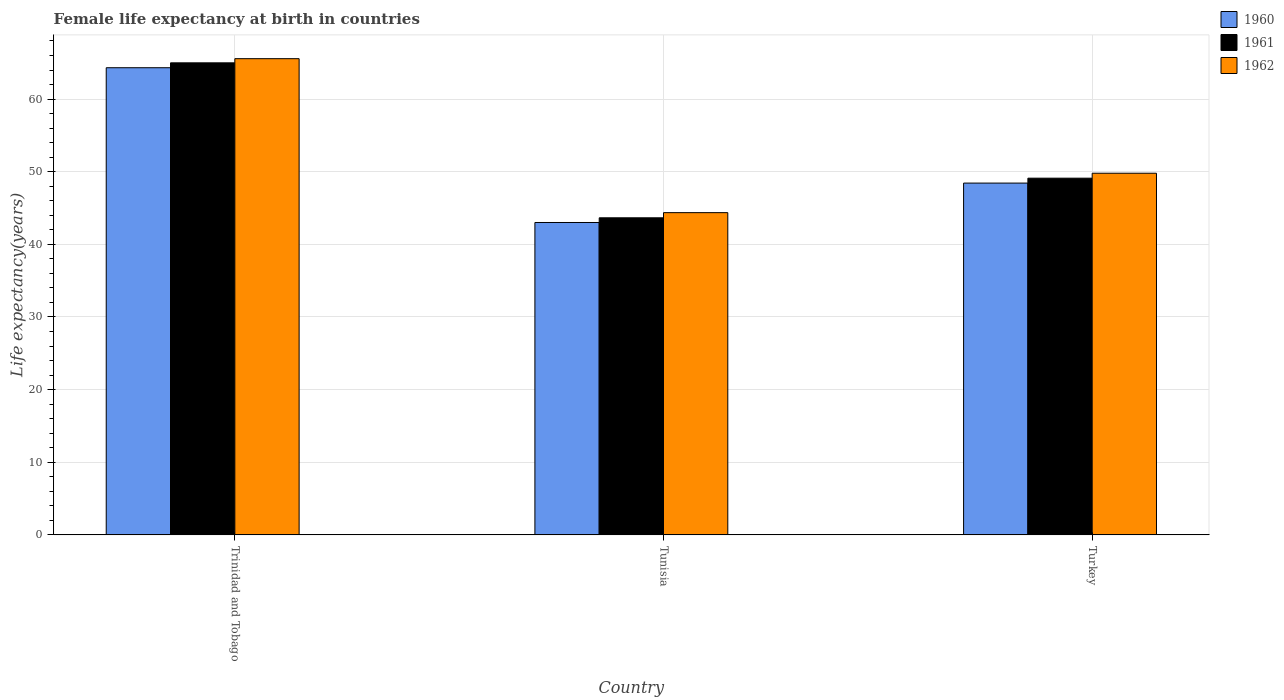How many groups of bars are there?
Offer a very short reply. 3. Are the number of bars per tick equal to the number of legend labels?
Ensure brevity in your answer.  Yes. What is the label of the 1st group of bars from the left?
Keep it short and to the point. Trinidad and Tobago. In how many cases, is the number of bars for a given country not equal to the number of legend labels?
Give a very brief answer. 0. What is the female life expectancy at birth in 1962 in Tunisia?
Your response must be concise. 44.36. Across all countries, what is the maximum female life expectancy at birth in 1960?
Your response must be concise. 64.31. Across all countries, what is the minimum female life expectancy at birth in 1961?
Give a very brief answer. 43.65. In which country was the female life expectancy at birth in 1962 maximum?
Your answer should be very brief. Trinidad and Tobago. In which country was the female life expectancy at birth in 1960 minimum?
Give a very brief answer. Tunisia. What is the total female life expectancy at birth in 1960 in the graph?
Provide a succinct answer. 155.75. What is the difference between the female life expectancy at birth in 1960 in Trinidad and Tobago and that in Tunisia?
Ensure brevity in your answer.  21.31. What is the difference between the female life expectancy at birth in 1962 in Tunisia and the female life expectancy at birth in 1960 in Trinidad and Tobago?
Provide a succinct answer. -19.95. What is the average female life expectancy at birth in 1962 per country?
Keep it short and to the point. 53.24. What is the difference between the female life expectancy at birth of/in 1961 and female life expectancy at birth of/in 1962 in Tunisia?
Give a very brief answer. -0.71. In how many countries, is the female life expectancy at birth in 1961 greater than 60 years?
Offer a very short reply. 1. What is the ratio of the female life expectancy at birth in 1961 in Tunisia to that in Turkey?
Make the answer very short. 0.89. What is the difference between the highest and the second highest female life expectancy at birth in 1962?
Provide a succinct answer. 21.2. What is the difference between the highest and the lowest female life expectancy at birth in 1961?
Give a very brief answer. 21.33. In how many countries, is the female life expectancy at birth in 1962 greater than the average female life expectancy at birth in 1962 taken over all countries?
Your response must be concise. 1. Is the sum of the female life expectancy at birth in 1962 in Trinidad and Tobago and Tunisia greater than the maximum female life expectancy at birth in 1960 across all countries?
Offer a very short reply. Yes. What does the 2nd bar from the left in Tunisia represents?
Provide a succinct answer. 1961. How many bars are there?
Offer a very short reply. 9. What is the difference between two consecutive major ticks on the Y-axis?
Offer a terse response. 10. Are the values on the major ticks of Y-axis written in scientific E-notation?
Offer a very short reply. No. Does the graph contain any zero values?
Offer a terse response. No. Where does the legend appear in the graph?
Ensure brevity in your answer.  Top right. How are the legend labels stacked?
Ensure brevity in your answer.  Vertical. What is the title of the graph?
Provide a short and direct response. Female life expectancy at birth in countries. What is the label or title of the Y-axis?
Provide a short and direct response. Life expectancy(years). What is the Life expectancy(years) in 1960 in Trinidad and Tobago?
Provide a short and direct response. 64.31. What is the Life expectancy(years) in 1961 in Trinidad and Tobago?
Ensure brevity in your answer.  64.99. What is the Life expectancy(years) of 1962 in Trinidad and Tobago?
Give a very brief answer. 65.56. What is the Life expectancy(years) in 1960 in Tunisia?
Your answer should be compact. 43.01. What is the Life expectancy(years) of 1961 in Tunisia?
Offer a terse response. 43.65. What is the Life expectancy(years) of 1962 in Tunisia?
Provide a short and direct response. 44.36. What is the Life expectancy(years) of 1960 in Turkey?
Give a very brief answer. 48.43. What is the Life expectancy(years) in 1961 in Turkey?
Your answer should be compact. 49.11. What is the Life expectancy(years) of 1962 in Turkey?
Provide a succinct answer. 49.79. Across all countries, what is the maximum Life expectancy(years) of 1960?
Keep it short and to the point. 64.31. Across all countries, what is the maximum Life expectancy(years) in 1961?
Make the answer very short. 64.99. Across all countries, what is the maximum Life expectancy(years) of 1962?
Your answer should be very brief. 65.56. Across all countries, what is the minimum Life expectancy(years) of 1960?
Your answer should be compact. 43.01. Across all countries, what is the minimum Life expectancy(years) in 1961?
Keep it short and to the point. 43.65. Across all countries, what is the minimum Life expectancy(years) in 1962?
Ensure brevity in your answer.  44.36. What is the total Life expectancy(years) in 1960 in the graph?
Offer a terse response. 155.75. What is the total Life expectancy(years) in 1961 in the graph?
Offer a terse response. 157.75. What is the total Life expectancy(years) of 1962 in the graph?
Ensure brevity in your answer.  159.71. What is the difference between the Life expectancy(years) in 1960 in Trinidad and Tobago and that in Tunisia?
Your answer should be compact. 21.31. What is the difference between the Life expectancy(years) in 1961 in Trinidad and Tobago and that in Tunisia?
Ensure brevity in your answer.  21.33. What is the difference between the Life expectancy(years) in 1962 in Trinidad and Tobago and that in Tunisia?
Keep it short and to the point. 21.2. What is the difference between the Life expectancy(years) of 1960 in Trinidad and Tobago and that in Turkey?
Your answer should be very brief. 15.88. What is the difference between the Life expectancy(years) of 1961 in Trinidad and Tobago and that in Turkey?
Ensure brevity in your answer.  15.88. What is the difference between the Life expectancy(years) of 1962 in Trinidad and Tobago and that in Turkey?
Provide a short and direct response. 15.77. What is the difference between the Life expectancy(years) in 1960 in Tunisia and that in Turkey?
Provide a short and direct response. -5.43. What is the difference between the Life expectancy(years) in 1961 in Tunisia and that in Turkey?
Make the answer very short. -5.46. What is the difference between the Life expectancy(years) in 1962 in Tunisia and that in Turkey?
Provide a short and direct response. -5.43. What is the difference between the Life expectancy(years) of 1960 in Trinidad and Tobago and the Life expectancy(years) of 1961 in Tunisia?
Offer a terse response. 20.66. What is the difference between the Life expectancy(years) in 1960 in Trinidad and Tobago and the Life expectancy(years) in 1962 in Tunisia?
Provide a short and direct response. 19.95. What is the difference between the Life expectancy(years) in 1961 in Trinidad and Tobago and the Life expectancy(years) in 1962 in Tunisia?
Your response must be concise. 20.62. What is the difference between the Life expectancy(years) of 1960 in Trinidad and Tobago and the Life expectancy(years) of 1961 in Turkey?
Keep it short and to the point. 15.21. What is the difference between the Life expectancy(years) in 1960 in Trinidad and Tobago and the Life expectancy(years) in 1962 in Turkey?
Make the answer very short. 14.52. What is the difference between the Life expectancy(years) in 1961 in Trinidad and Tobago and the Life expectancy(years) in 1962 in Turkey?
Your response must be concise. 15.2. What is the difference between the Life expectancy(years) in 1960 in Tunisia and the Life expectancy(years) in 1961 in Turkey?
Ensure brevity in your answer.  -6.1. What is the difference between the Life expectancy(years) in 1960 in Tunisia and the Life expectancy(years) in 1962 in Turkey?
Your response must be concise. -6.78. What is the difference between the Life expectancy(years) in 1961 in Tunisia and the Life expectancy(years) in 1962 in Turkey?
Provide a short and direct response. -6.14. What is the average Life expectancy(years) of 1960 per country?
Provide a succinct answer. 51.92. What is the average Life expectancy(years) in 1961 per country?
Make the answer very short. 52.58. What is the average Life expectancy(years) of 1962 per country?
Provide a short and direct response. 53.24. What is the difference between the Life expectancy(years) in 1960 and Life expectancy(years) in 1961 in Trinidad and Tobago?
Provide a succinct answer. -0.67. What is the difference between the Life expectancy(years) of 1960 and Life expectancy(years) of 1962 in Trinidad and Tobago?
Give a very brief answer. -1.25. What is the difference between the Life expectancy(years) in 1961 and Life expectancy(years) in 1962 in Trinidad and Tobago?
Offer a very short reply. -0.57. What is the difference between the Life expectancy(years) of 1960 and Life expectancy(years) of 1961 in Tunisia?
Your response must be concise. -0.65. What is the difference between the Life expectancy(years) in 1960 and Life expectancy(years) in 1962 in Tunisia?
Offer a terse response. -1.36. What is the difference between the Life expectancy(years) of 1961 and Life expectancy(years) of 1962 in Tunisia?
Offer a very short reply. -0.71. What is the difference between the Life expectancy(years) of 1960 and Life expectancy(years) of 1961 in Turkey?
Your answer should be compact. -0.68. What is the difference between the Life expectancy(years) in 1960 and Life expectancy(years) in 1962 in Turkey?
Ensure brevity in your answer.  -1.36. What is the difference between the Life expectancy(years) in 1961 and Life expectancy(years) in 1962 in Turkey?
Give a very brief answer. -0.68. What is the ratio of the Life expectancy(years) of 1960 in Trinidad and Tobago to that in Tunisia?
Give a very brief answer. 1.5. What is the ratio of the Life expectancy(years) of 1961 in Trinidad and Tobago to that in Tunisia?
Offer a terse response. 1.49. What is the ratio of the Life expectancy(years) of 1962 in Trinidad and Tobago to that in Tunisia?
Your response must be concise. 1.48. What is the ratio of the Life expectancy(years) of 1960 in Trinidad and Tobago to that in Turkey?
Ensure brevity in your answer.  1.33. What is the ratio of the Life expectancy(years) of 1961 in Trinidad and Tobago to that in Turkey?
Your answer should be very brief. 1.32. What is the ratio of the Life expectancy(years) of 1962 in Trinidad and Tobago to that in Turkey?
Offer a terse response. 1.32. What is the ratio of the Life expectancy(years) of 1960 in Tunisia to that in Turkey?
Provide a succinct answer. 0.89. What is the ratio of the Life expectancy(years) in 1962 in Tunisia to that in Turkey?
Offer a very short reply. 0.89. What is the difference between the highest and the second highest Life expectancy(years) in 1960?
Provide a short and direct response. 15.88. What is the difference between the highest and the second highest Life expectancy(years) in 1961?
Your answer should be very brief. 15.88. What is the difference between the highest and the second highest Life expectancy(years) of 1962?
Your answer should be very brief. 15.77. What is the difference between the highest and the lowest Life expectancy(years) in 1960?
Make the answer very short. 21.31. What is the difference between the highest and the lowest Life expectancy(years) of 1961?
Offer a very short reply. 21.33. What is the difference between the highest and the lowest Life expectancy(years) of 1962?
Offer a very short reply. 21.2. 